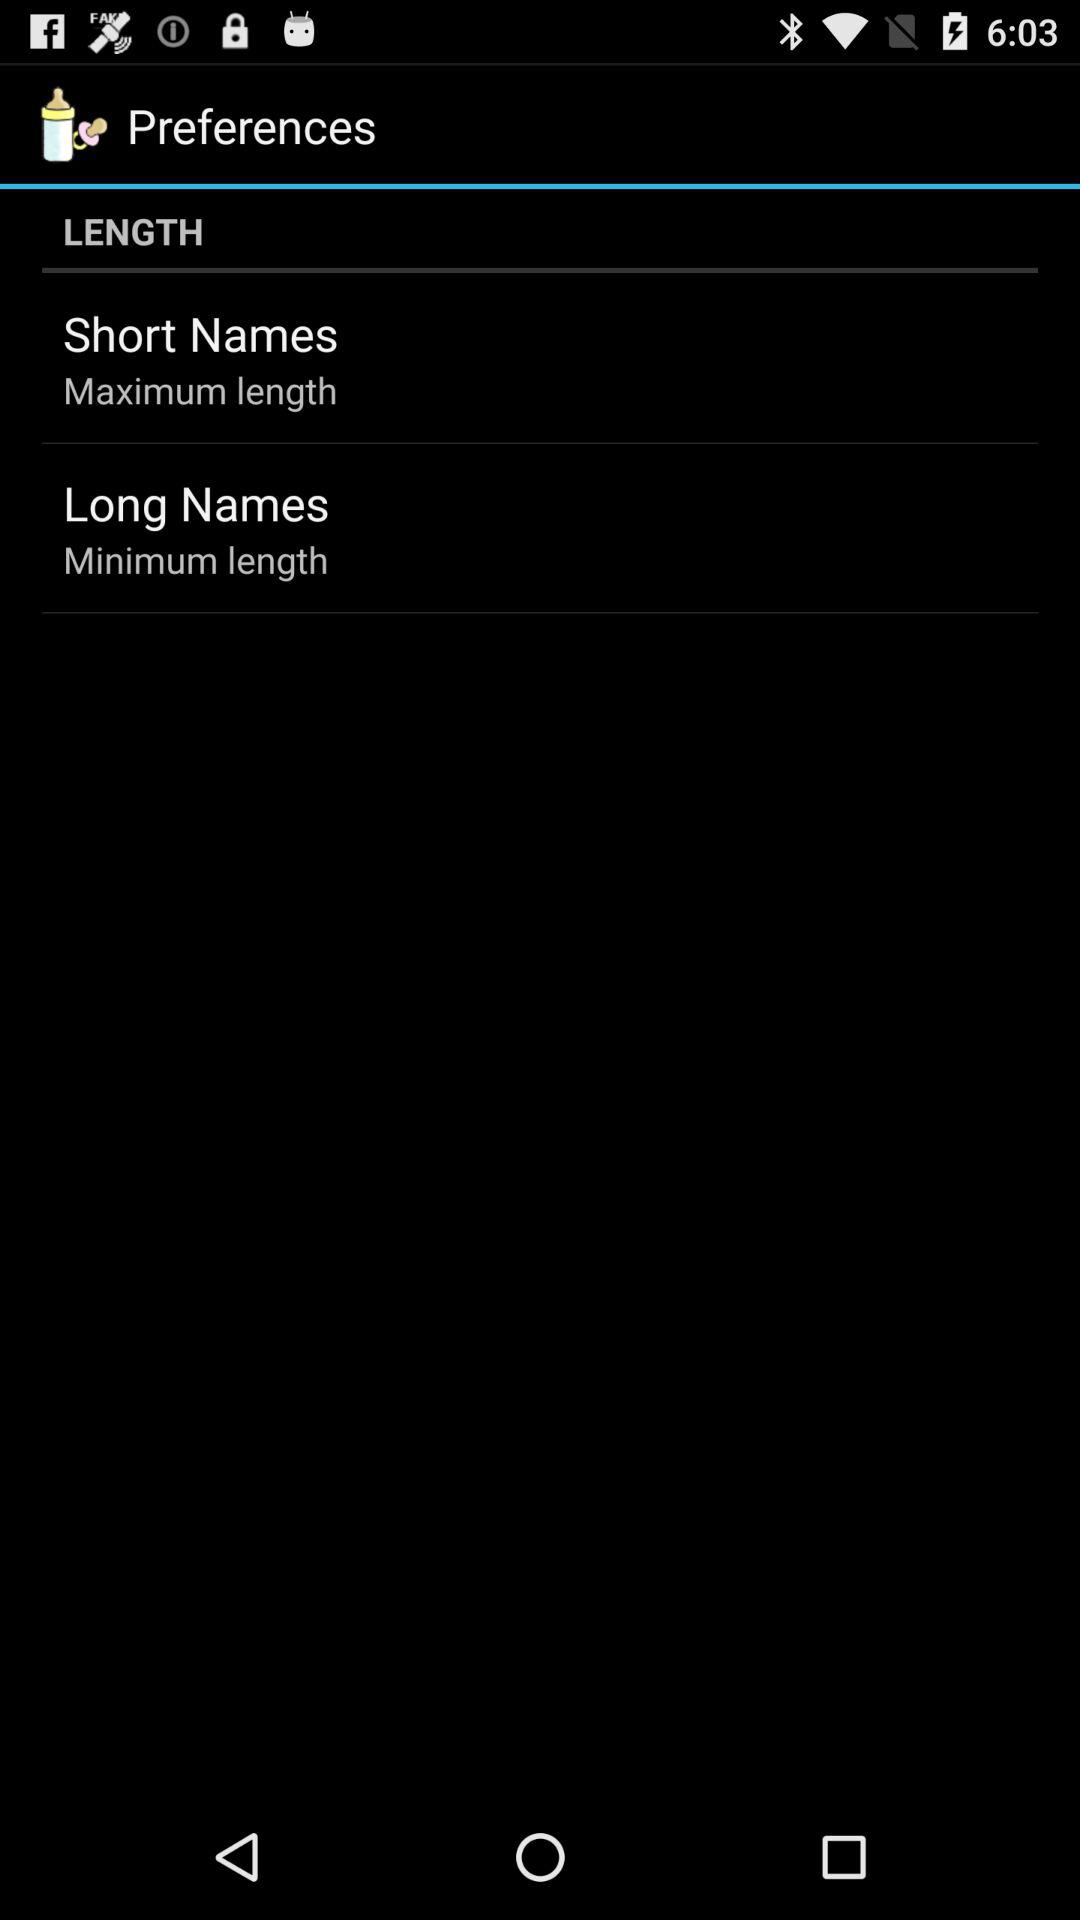What is the length of "Long Names"? The length is "Minimum". 